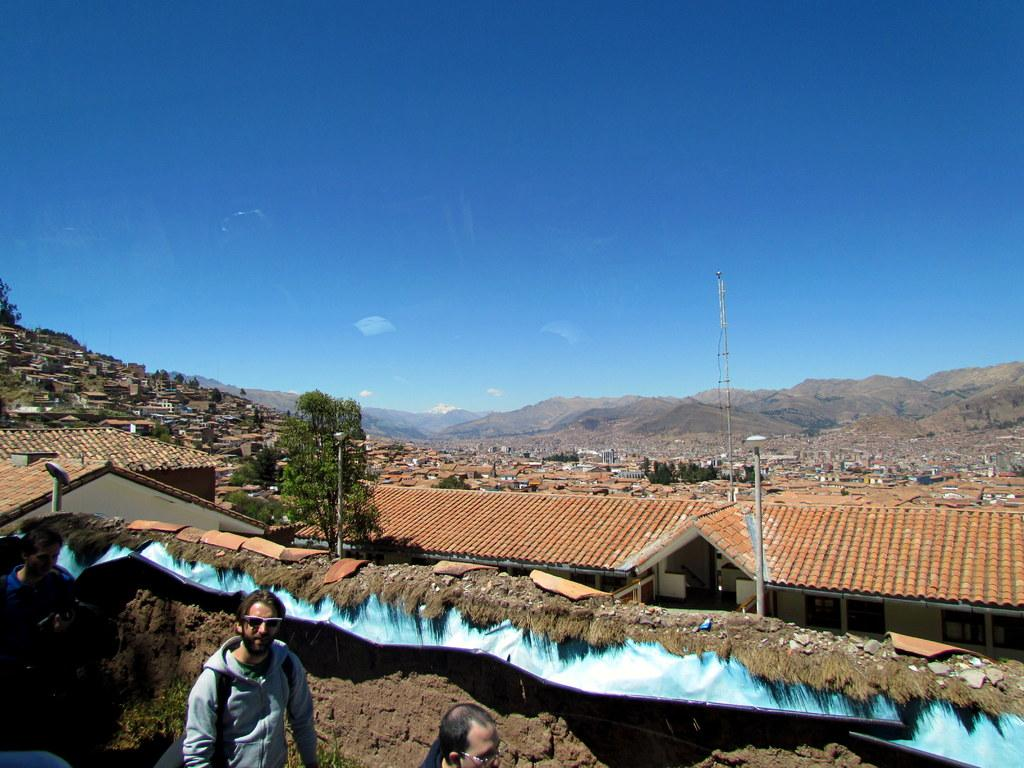How many people are present in the image? There are three people in the image. What type of structures can be seen in the image? There are buildings in the image. What natural elements are present in the image? There are trees and mountains in the image. What man-made objects can be seen in the image? There are poles in the image. What else can be seen in the image besides the people, buildings, trees, mountains, and poles? There are some objects in the image. What is visible in the background of the image? The sky is visible in the background of the image. What type of mint is growing on the authority figure's hat in the image? There is no mint or authority figure present in the image. 